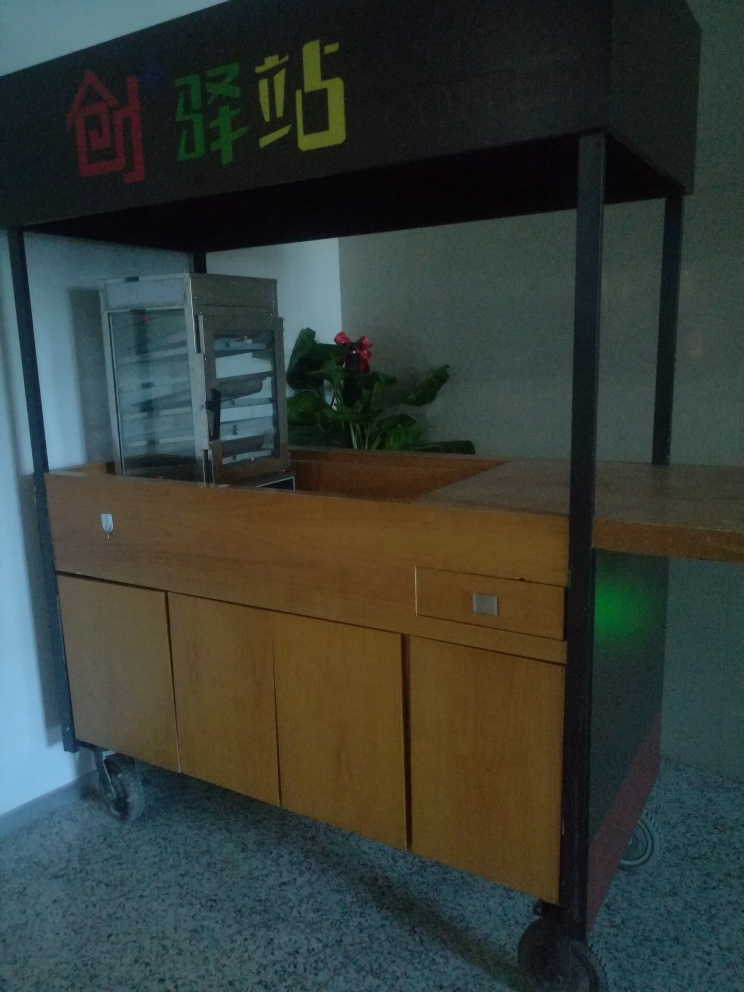Can you describe the setting or what this establishment might be? This image features a food serving counter, which could typically be found in a cafeteria or buffet setting. The signage in bright colorful characters hints that it might be situated within a school or a casual dining venue, offering a selection of food or snacks to patrons. 